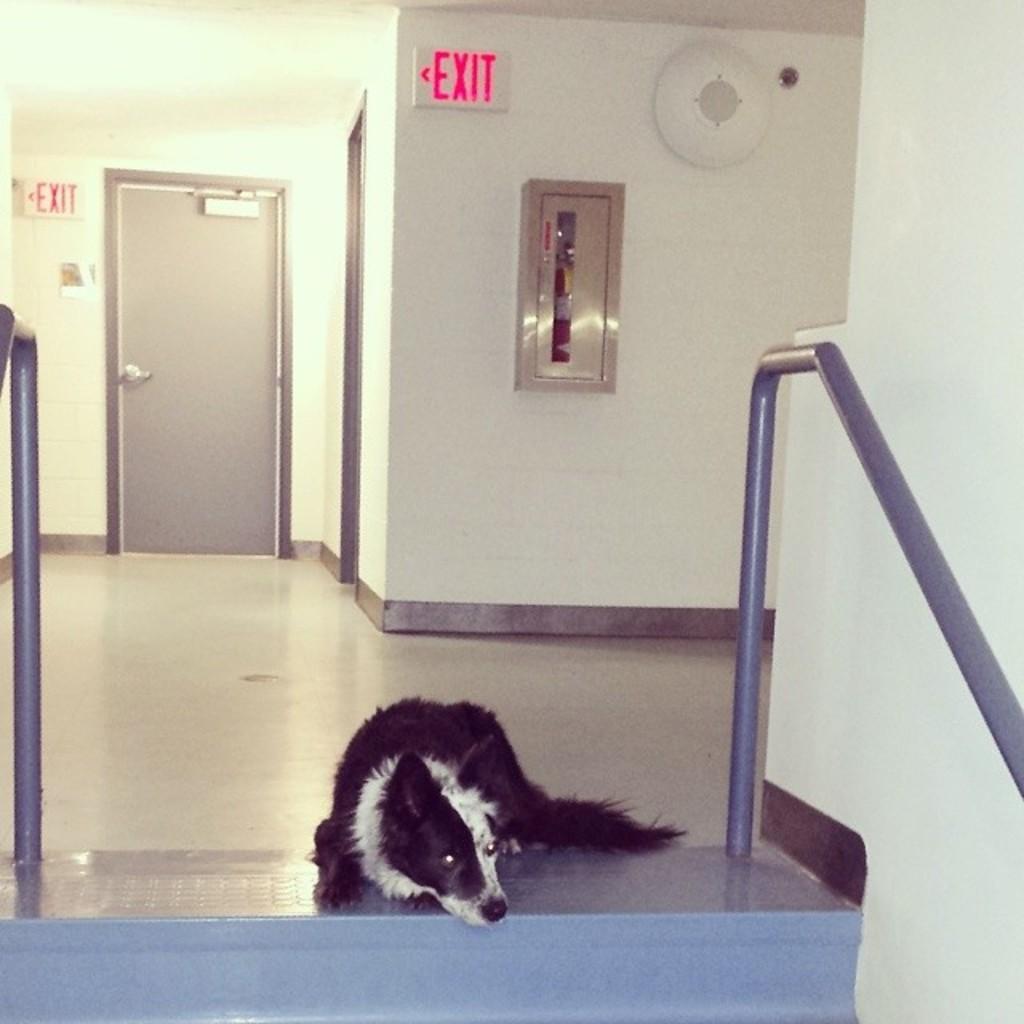How would you summarize this image in a sentence or two? In this image we can see rods, walls, exit boards and door. Dog is sleeping on the floor. 